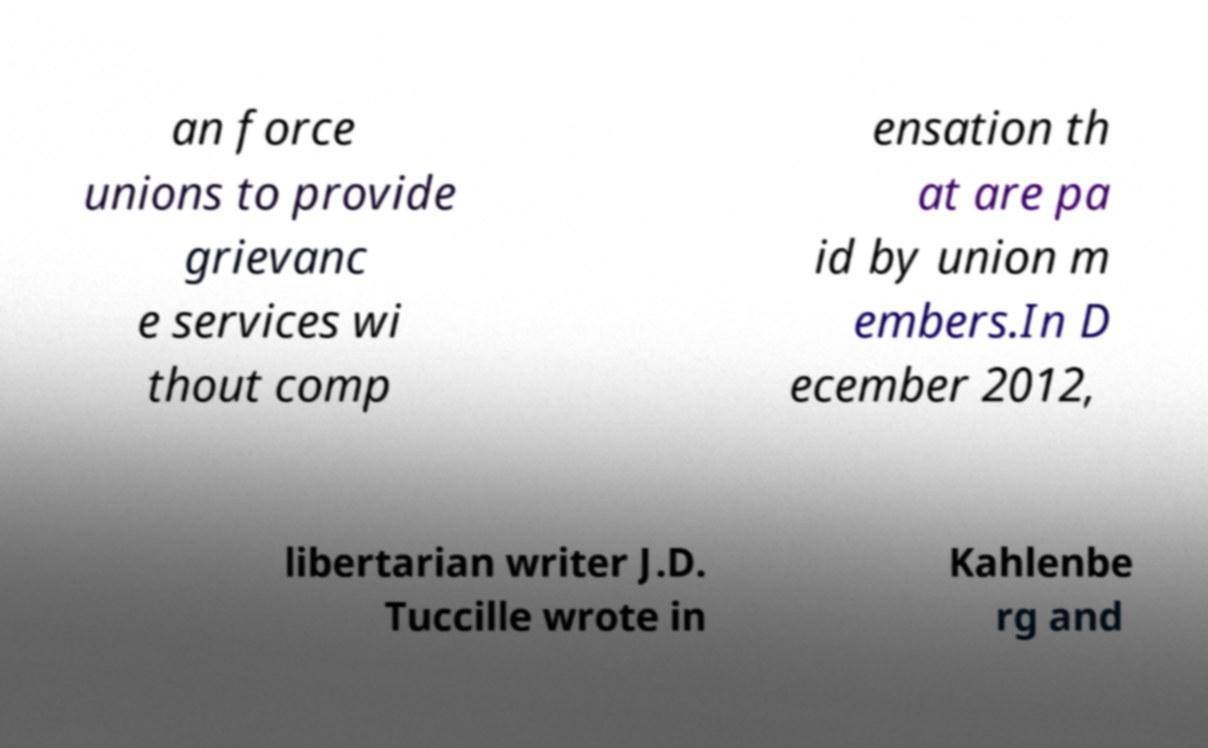Please identify and transcribe the text found in this image. an force unions to provide grievanc e services wi thout comp ensation th at are pa id by union m embers.In D ecember 2012, libertarian writer J.D. Tuccille wrote in Kahlenbe rg and 